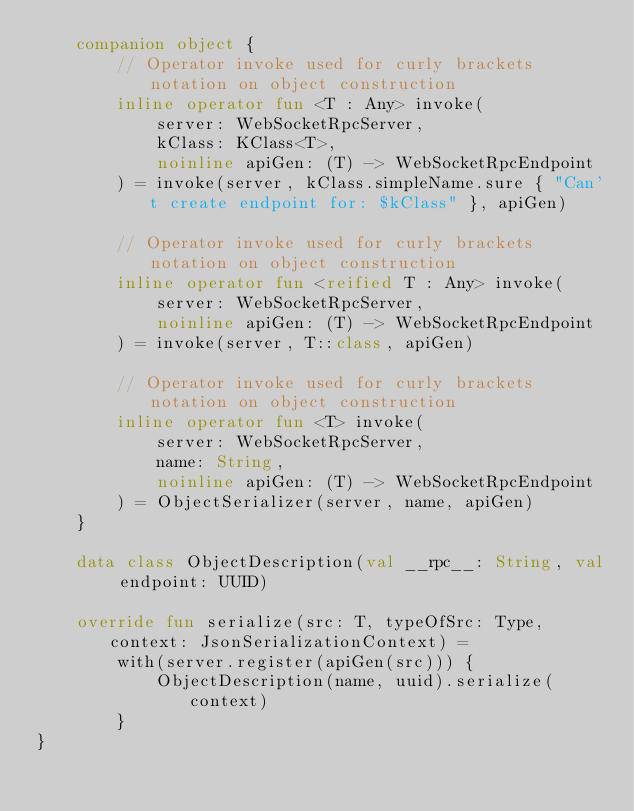Convert code to text. <code><loc_0><loc_0><loc_500><loc_500><_Kotlin_>    companion object {
        // Operator invoke used for curly brackets notation on object construction
        inline operator fun <T : Any> invoke(
            server: WebSocketRpcServer,
            kClass: KClass<T>,
            noinline apiGen: (T) -> WebSocketRpcEndpoint
        ) = invoke(server, kClass.simpleName.sure { "Can't create endpoint for: $kClass" }, apiGen)

        // Operator invoke used for curly brackets notation on object construction
        inline operator fun <reified T : Any> invoke(
            server: WebSocketRpcServer,
            noinline apiGen: (T) -> WebSocketRpcEndpoint
        ) = invoke(server, T::class, apiGen)

        // Operator invoke used for curly brackets notation on object construction
        inline operator fun <T> invoke(
            server: WebSocketRpcServer,
            name: String,
            noinline apiGen: (T) -> WebSocketRpcEndpoint
        ) = ObjectSerializer(server, name, apiGen)
    }

    data class ObjectDescription(val __rpc__: String, val endpoint: UUID)

    override fun serialize(src: T, typeOfSrc: Type, context: JsonSerializationContext) =
        with(server.register(apiGen(src))) {
            ObjectDescription(name, uuid).serialize(context)
        }
}</code> 